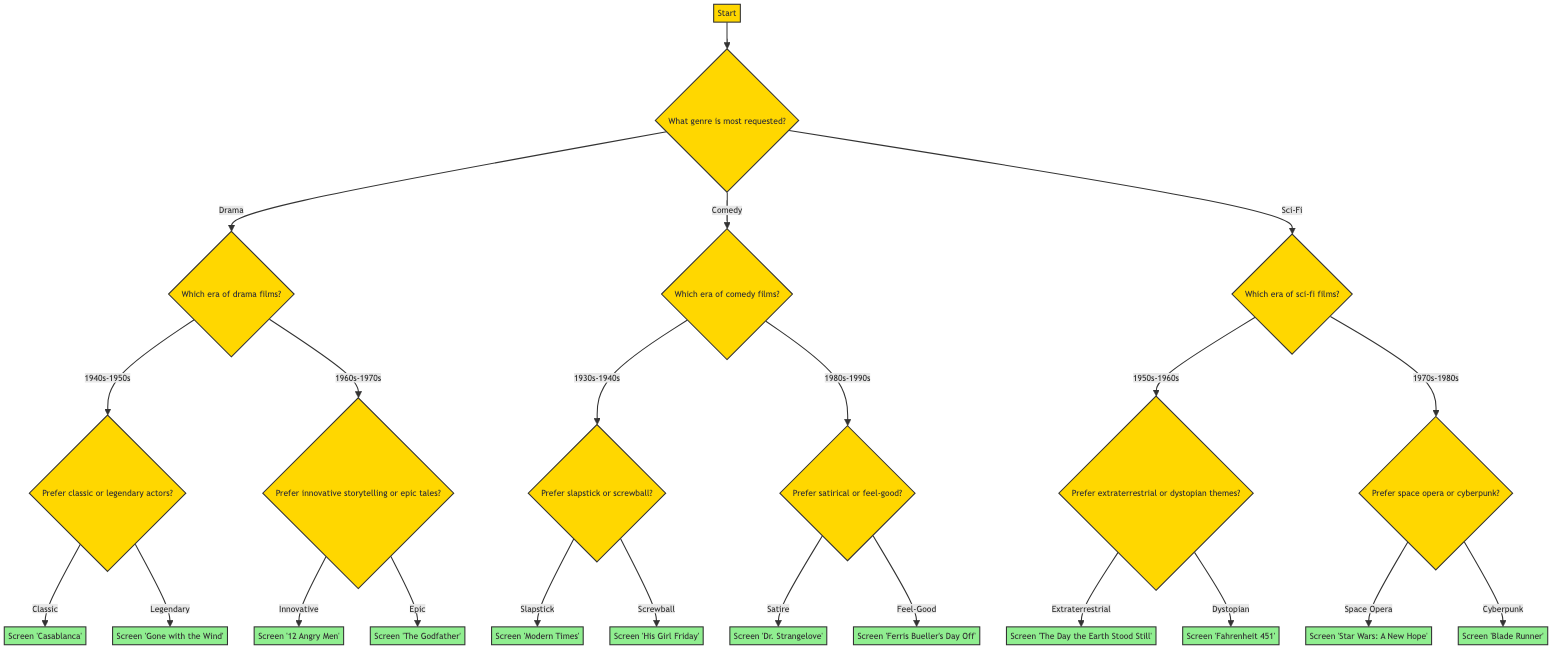What is the first question in the decision tree? The first question in the decision tree is found at the starting node labeled "Start." It asks, "What genre is most requested by audiences?"
Answer: What genre is most requested by audiences? How many main genres are presented in the decision tree? The decision tree branches into three main genres: Drama, Comedy, and Sci-Fi. Therefore, there are three distinct main genres present.
Answer: Three What is the output if the audience prefers epic tales in drama? If the audience prefers epic tales, we follow the path from "What genre is most requested?" to "Drama," then to "Which era of drama films?" where we choose "1960s-1970s," and finally to "Prefer innovative storytelling or epic tales?" choosing "Epic," which leads us to screen "The Godfather."
Answer: Screen 'The Godfather' Which comedy movie is shown for those who prefer slapstick from the 1930s-1940s? Following the decision tree, if the audience is looking at "Comedy" and chooses the era "1930s-1940s," then preferring "slapstick" leads to the output of "Modern Times."
Answer: Screen 'Modern Times' What are two options available for the audience interested in sci-fi films from the 1970s-1980s? In the decision tree, after choosing "Sci-Fi" and examining the era "1970s-1980s," the audience has the options of preferring either "space opera," which leads to screening "Star Wars: A New Hope," or "cyberpunk," which leads to screening "Blade Runner."
Answer: Space Opera, Cyberpunk What unique question distinguishes classic and legendary actors in the drama section? In the drama section of the decision tree, the unique question that distinguishes classic and legendary actors is, "Prefer classic or legendary actors?" This decision leads to two different movie outputs related to each type of actor.
Answer: Prefer classic or legendary actors? 